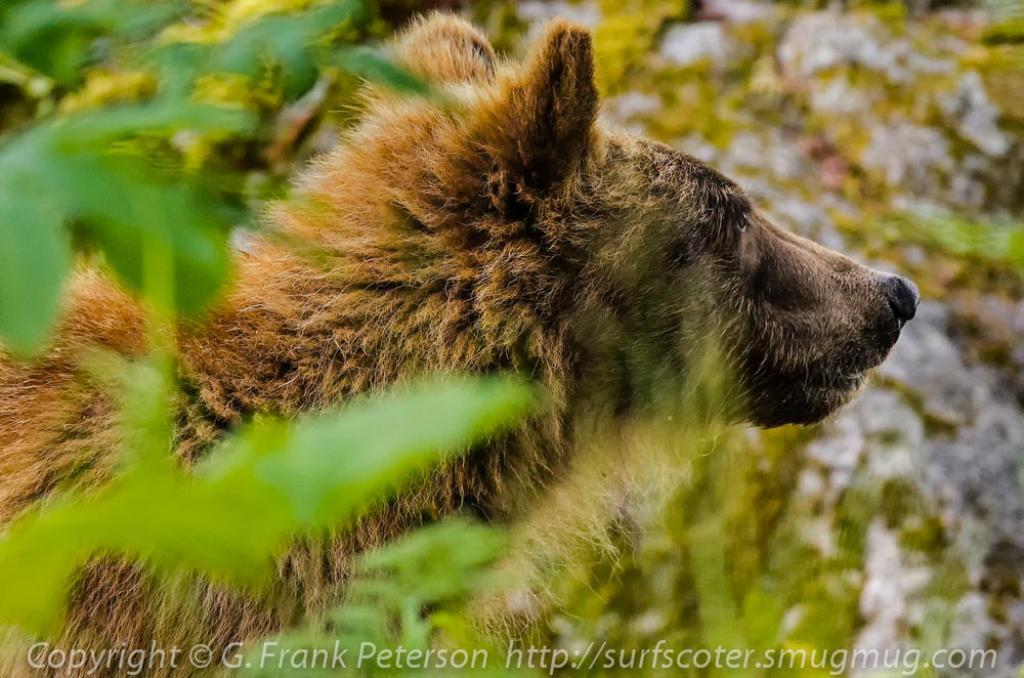What can be found at the bottom of the image? There is a watermark at the bottom of the image. What is located on the left side of the image? There is an animal on the left side of the image. What is present beside the animal? There are leaves of trees beside the animal. How would you describe the background of the image? The background of the image is blurred. What scent can be detected from the animal in the image? There is no information about the scent of the animal in the image, as it is a visual medium. How many legs does the animal have in the image? The number of legs the animal has cannot be determined from the image alone, as it is not clear enough to see the legs. 